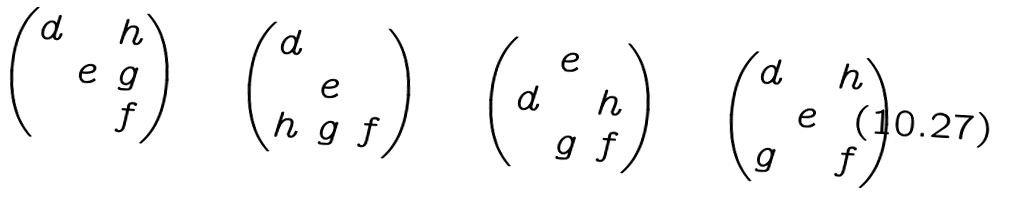<formula> <loc_0><loc_0><loc_500><loc_500>\begin{pmatrix} d & & h \\ & e & g \\ & & f \end{pmatrix} \quad \begin{pmatrix} d & & \\ & e & \\ h & g & f \end{pmatrix} \quad \begin{pmatrix} & e & \\ d & & h \\ & g & f \end{pmatrix} \quad \begin{pmatrix} d & & h \\ & e & \\ g & & f \end{pmatrix}</formula> 